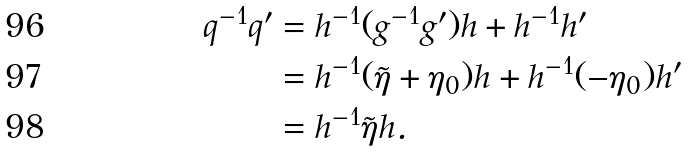Convert formula to latex. <formula><loc_0><loc_0><loc_500><loc_500>q ^ { - 1 } q ^ { \prime } & = h ^ { - 1 } ( g ^ { - 1 } g ^ { \prime } ) h + h ^ { - 1 } h ^ { \prime } \\ & = h ^ { - 1 } ( \tilde { \eta } + \eta _ { 0 } ) h + h ^ { - 1 } ( - \eta _ { 0 } ) h ^ { \prime } \\ & = h ^ { - 1 } \tilde { \eta } h .</formula> 